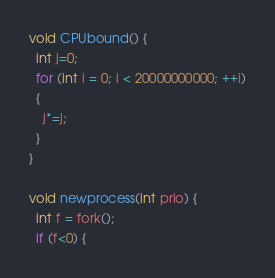Convert code to text. <code><loc_0><loc_0><loc_500><loc_500><_C_>void CPUbound() {
  int j=0;
  for (int i = 0; i < 20000000000; ++i)
  {
    j*=j;
  }
}

void newprocess(int prio) {
  int f = fork();
  if (f<0) {</code> 